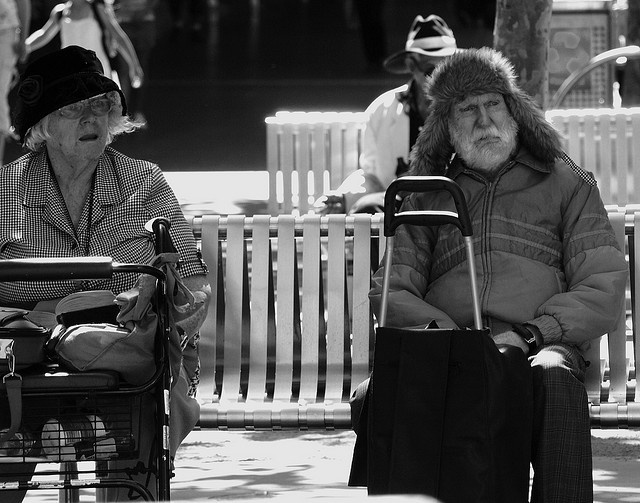Describe the objects in this image and their specific colors. I can see people in darkgray, black, gray, and lightgray tones, bench in darkgray, gray, black, and lightgray tones, suitcase in darkgray, black, gray, and lightgray tones, people in darkgray, black, gray, and lightgray tones, and bench in darkgray, lightgray, gray, and black tones in this image. 